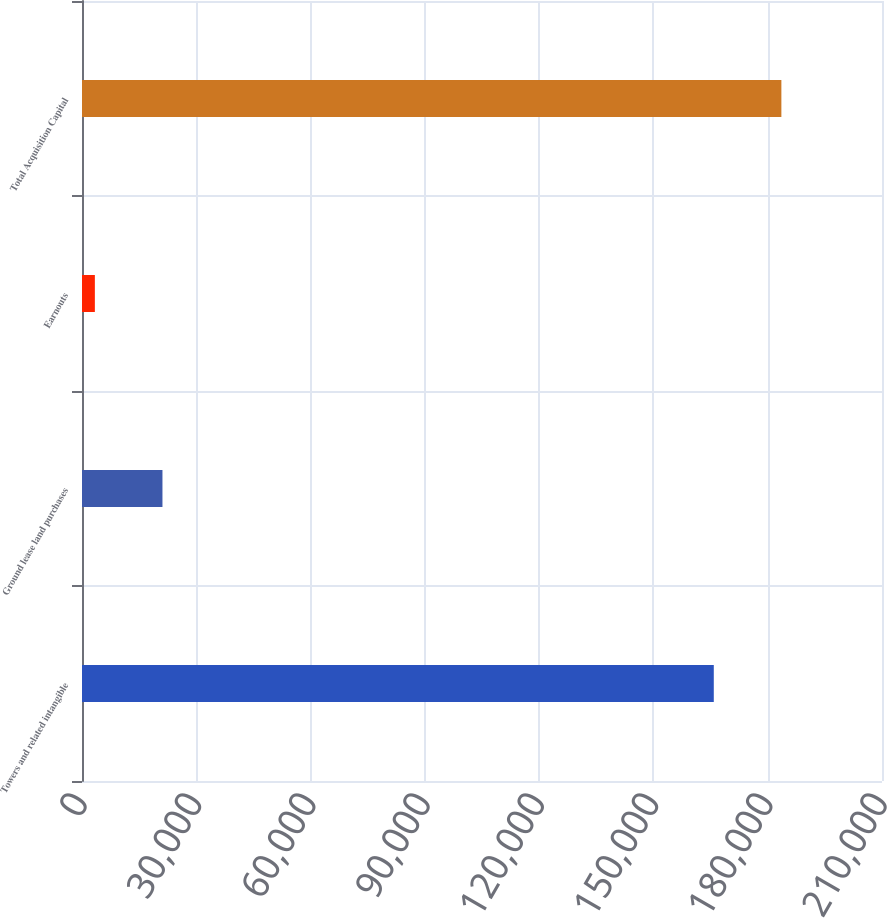Convert chart. <chart><loc_0><loc_0><loc_500><loc_500><bar_chart><fcel>Towers and related intangible<fcel>Ground lease land purchases<fcel>Earnouts<fcel>Total Acquisition Capital<nl><fcel>165844<fcel>21119.1<fcel>3377<fcel>183586<nl></chart> 